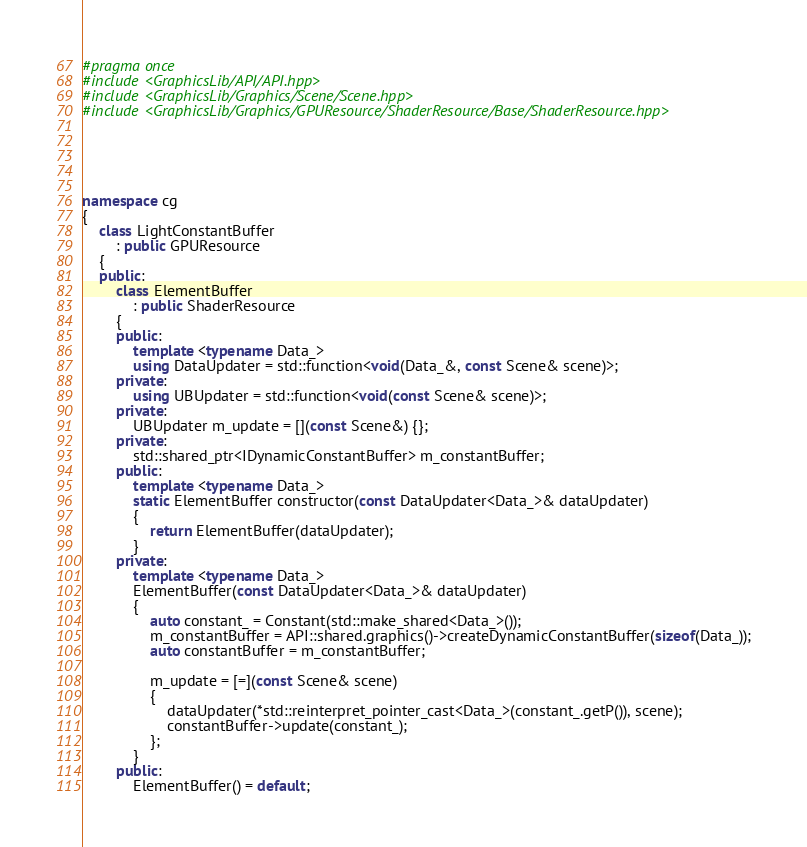Convert code to text. <code><loc_0><loc_0><loc_500><loc_500><_C++_>#pragma once
#include <GraphicsLib/API/API.hpp>
#include <GraphicsLib/Graphics/Scene/Scene.hpp>
#include <GraphicsLib/Graphics/GPUResource/ShaderResource/Base/ShaderResource.hpp>





namespace cg
{
	class LightConstantBuffer
		: public GPUResource
	{
	public:
		class ElementBuffer
			: public ShaderResource
		{
		public:
			template <typename Data_>
			using DataUpdater = std::function<void(Data_&, const Scene& scene)>;
		private:
			using UBUpdater = std::function<void(const Scene& scene)>;
		private:
			UBUpdater m_update = [](const Scene&) {};
		private:
			std::shared_ptr<IDynamicConstantBuffer> m_constantBuffer;
		public:
			template <typename Data_>
			static ElementBuffer constructor(const DataUpdater<Data_>& dataUpdater)
			{
				return ElementBuffer(dataUpdater);
			}
		private:
			template <typename Data_>
			ElementBuffer(const DataUpdater<Data_>& dataUpdater)
			{
				auto constant_ = Constant(std::make_shared<Data_>());
				m_constantBuffer = API::shared.graphics()->createDynamicConstantBuffer(sizeof(Data_));
				auto constantBuffer = m_constantBuffer;

				m_update = [=](const Scene& scene)
				{
					dataUpdater(*std::reinterpret_pointer_cast<Data_>(constant_.getP()), scene);
					constantBuffer->update(constant_);
				};
			}
		public:
			ElementBuffer() = default;</code> 